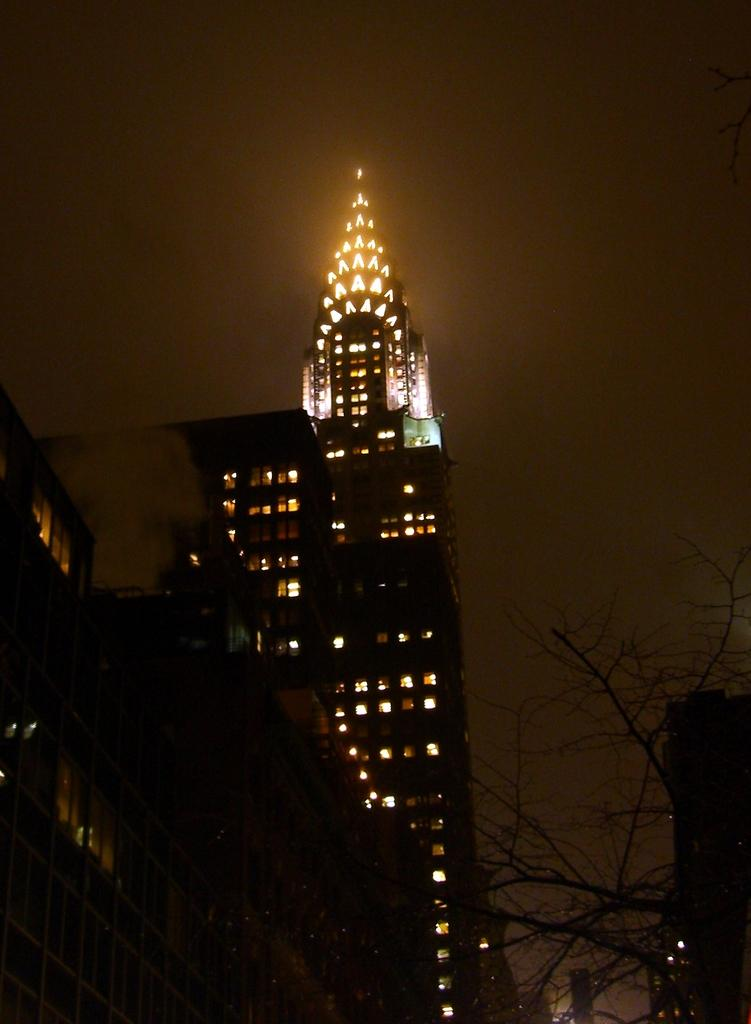What is the main subject in the center of the image? There is a building with lights in the center of the image. What can be seen in the background of the image? There are trees in the background of the image. What is visible at the top of the image? The sky is visible at the top of the image. What type of jeans is the girl wearing in the image? There is no girl present in the image, so it is not possible to determine what type of jeans she might be wearing. 